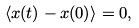<formula> <loc_0><loc_0><loc_500><loc_500>\langle x ( t ) - x ( 0 ) \rangle = 0 ,</formula> 